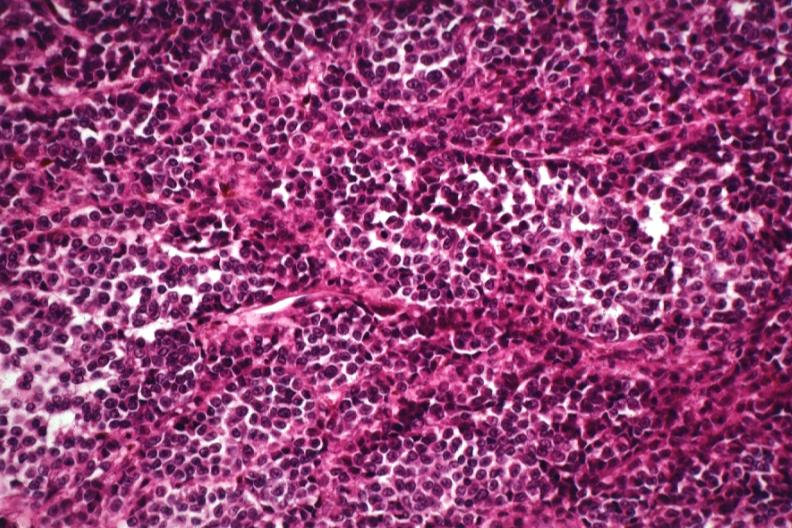does this image show cells deep in skin lesion with no pigment?
Answer the question using a single word or phrase. Yes 